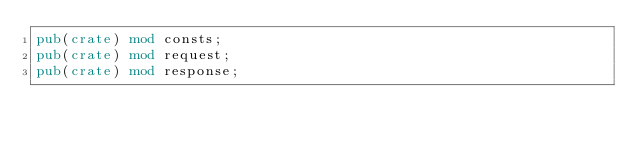<code> <loc_0><loc_0><loc_500><loc_500><_Rust_>pub(crate) mod consts;
pub(crate) mod request;
pub(crate) mod response;
</code> 